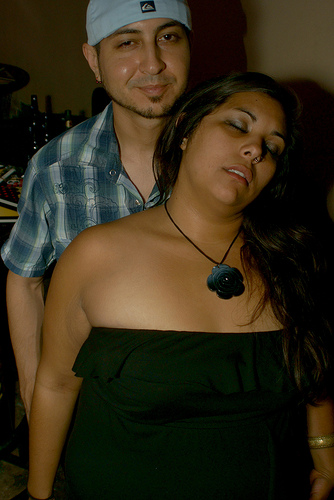<image>
Is the woman next to the man? No. The woman is not positioned next to the man. They are located in different areas of the scene. 